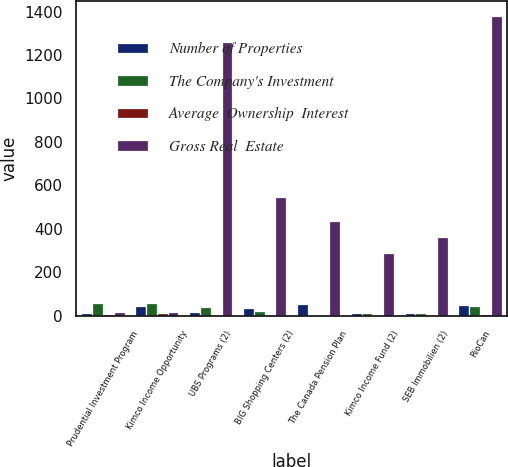<chart> <loc_0><loc_0><loc_500><loc_500><stacked_bar_chart><ecel><fcel>Prudential Investment Program<fcel>Kimco Income Opportunity<fcel>UBS Programs (2)<fcel>BIG Shopping Centers (2)<fcel>The Canada Pension Plan<fcel>Kimco Income Fund (2)<fcel>SEB Immobilien (2)<fcel>RioCan<nl><fcel>Number of Properties<fcel>15<fcel>45<fcel>17.9<fcel>37.7<fcel>55<fcel>15.2<fcel>15<fcel>50<nl><fcel>The Company's Investment<fcel>61<fcel>58<fcel>40<fcel>22<fcel>6<fcel>12<fcel>13<fcel>45<nl><fcel>Average  Ownership  Interest<fcel>10.7<fcel>12.4<fcel>5.7<fcel>3.6<fcel>2.4<fcel>1.5<fcel>1.8<fcel>9.3<nl><fcel>Gross Real  Estate<fcel>19.95<fcel>19.95<fcel>1260.1<fcel>547.7<fcel>436.1<fcel>287<fcel>361.2<fcel>1379.3<nl></chart> 